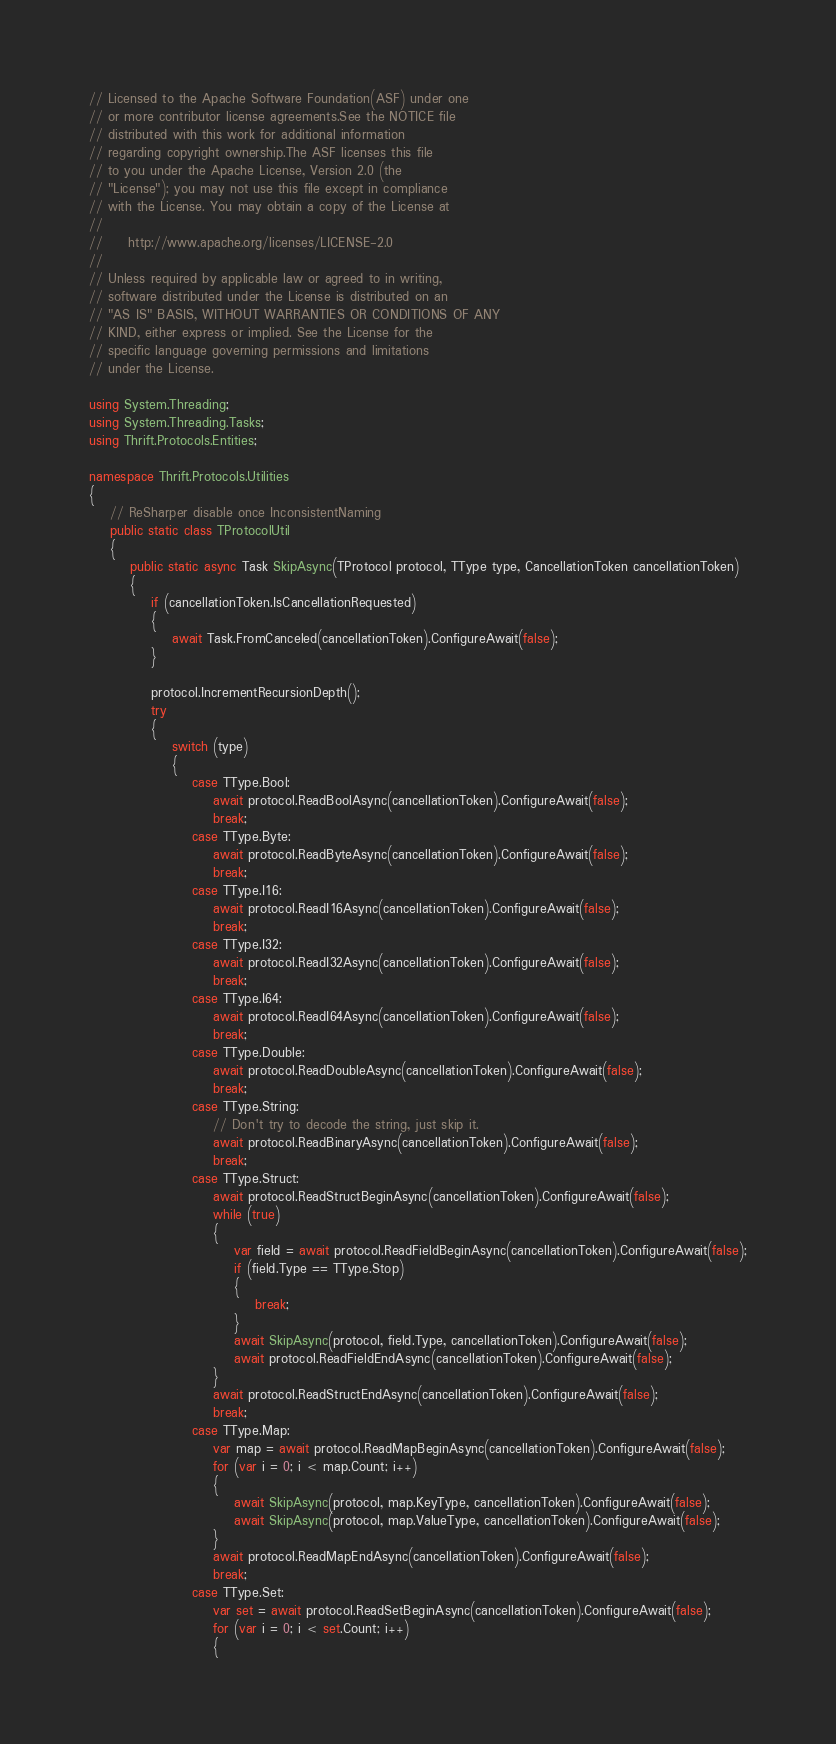<code> <loc_0><loc_0><loc_500><loc_500><_C#_>// Licensed to the Apache Software Foundation(ASF) under one
// or more contributor license agreements.See the NOTICE file
// distributed with this work for additional information
// regarding copyright ownership.The ASF licenses this file
// to you under the Apache License, Version 2.0 (the
// "License"); you may not use this file except in compliance
// with the License. You may obtain a copy of the License at
// 
//     http://www.apache.org/licenses/LICENSE-2.0
// 
// Unless required by applicable law or agreed to in writing,
// software distributed under the License is distributed on an
// "AS IS" BASIS, WITHOUT WARRANTIES OR CONDITIONS OF ANY
// KIND, either express or implied. See the License for the
// specific language governing permissions and limitations
// under the License.

using System.Threading;
using System.Threading.Tasks;
using Thrift.Protocols.Entities;

namespace Thrift.Protocols.Utilities
{
    // ReSharper disable once InconsistentNaming
    public static class TProtocolUtil
    {
        public static async Task SkipAsync(TProtocol protocol, TType type, CancellationToken cancellationToken)
        {
            if (cancellationToken.IsCancellationRequested)
            {
                await Task.FromCanceled(cancellationToken).ConfigureAwait(false);
            }

            protocol.IncrementRecursionDepth();
            try
            {
                switch (type)
                {
                    case TType.Bool:
                        await protocol.ReadBoolAsync(cancellationToken).ConfigureAwait(false);
                        break;
                    case TType.Byte:
                        await protocol.ReadByteAsync(cancellationToken).ConfigureAwait(false);
                        break;
                    case TType.I16:
                        await protocol.ReadI16Async(cancellationToken).ConfigureAwait(false);
                        break;
                    case TType.I32:
                        await protocol.ReadI32Async(cancellationToken).ConfigureAwait(false);
                        break;
                    case TType.I64:
                        await protocol.ReadI64Async(cancellationToken).ConfigureAwait(false);
                        break;
                    case TType.Double:
                        await protocol.ReadDoubleAsync(cancellationToken).ConfigureAwait(false);
                        break;
                    case TType.String:
                        // Don't try to decode the string, just skip it.
                        await protocol.ReadBinaryAsync(cancellationToken).ConfigureAwait(false);
                        break;
                    case TType.Struct:
                        await protocol.ReadStructBeginAsync(cancellationToken).ConfigureAwait(false);
                        while (true)
                        {
                            var field = await protocol.ReadFieldBeginAsync(cancellationToken).ConfigureAwait(false);
                            if (field.Type == TType.Stop)
                            {
                                break;
                            }
                            await SkipAsync(protocol, field.Type, cancellationToken).ConfigureAwait(false);
                            await protocol.ReadFieldEndAsync(cancellationToken).ConfigureAwait(false);
                        }
                        await protocol.ReadStructEndAsync(cancellationToken).ConfigureAwait(false);
                        break;
                    case TType.Map:
                        var map = await protocol.ReadMapBeginAsync(cancellationToken).ConfigureAwait(false);
                        for (var i = 0; i < map.Count; i++)
                        {
                            await SkipAsync(protocol, map.KeyType, cancellationToken).ConfigureAwait(false);
                            await SkipAsync(protocol, map.ValueType, cancellationToken).ConfigureAwait(false);
                        }
                        await protocol.ReadMapEndAsync(cancellationToken).ConfigureAwait(false);
                        break;
                    case TType.Set:
                        var set = await protocol.ReadSetBeginAsync(cancellationToken).ConfigureAwait(false);
                        for (var i = 0; i < set.Count; i++)
                        {</code> 